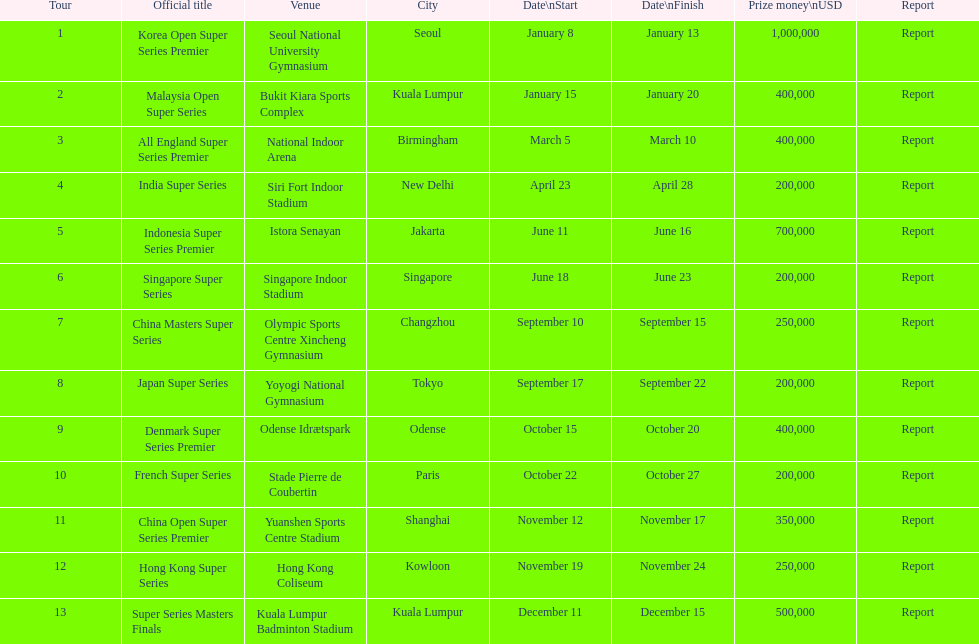What is the duration of the japan super series in days? 5. 